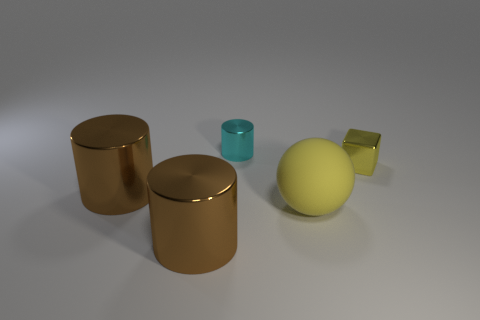Subtract all large cylinders. How many cylinders are left? 1 Subtract all cyan cylinders. How many cylinders are left? 2 Add 5 small matte cylinders. How many objects exist? 10 Subtract all yellow cubes. How many brown cylinders are left? 2 Subtract all blocks. How many objects are left? 4 Add 5 large cylinders. How many large cylinders are left? 7 Add 2 large rubber objects. How many large rubber objects exist? 3 Subtract 0 green cylinders. How many objects are left? 5 Subtract all brown cylinders. Subtract all cyan blocks. How many cylinders are left? 1 Subtract all large rubber things. Subtract all small yellow cubes. How many objects are left? 3 